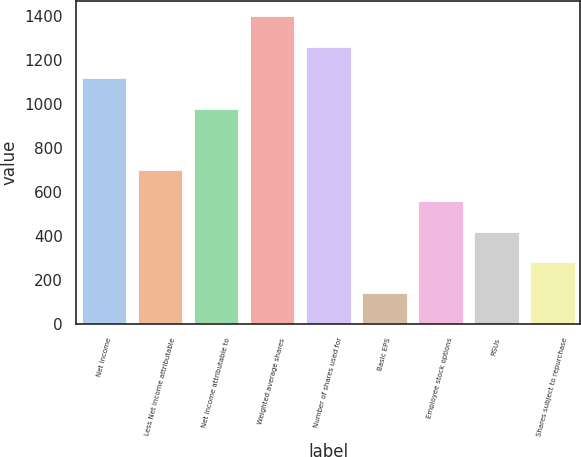<chart> <loc_0><loc_0><loc_500><loc_500><bar_chart><fcel>Net income<fcel>Less Net income attributable<fcel>Net income attributable to<fcel>Weighted average shares<fcel>Number of shares used for<fcel>Basic EPS<fcel>Employee stock options<fcel>RSUs<fcel>Shares subject to repurchase<nl><fcel>1118.46<fcel>699.21<fcel>978.71<fcel>1397.96<fcel>1258.21<fcel>140.21<fcel>559.46<fcel>419.71<fcel>279.96<nl></chart> 